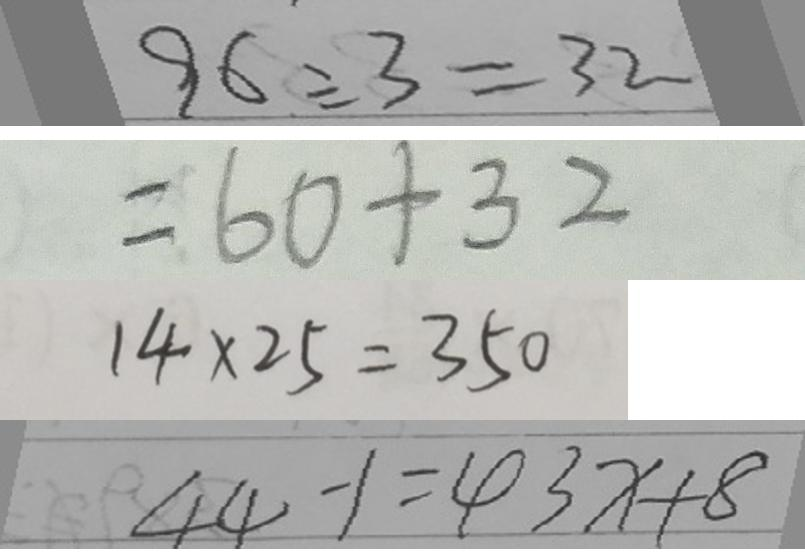Convert formula to latex. <formula><loc_0><loc_0><loc_500><loc_500>9 6 \div 3 = 3 2 
 = 6 0 + 3 2 
 1 4 \times 2 5 = 3 5 0 
 4 4 - 1 = 4 3 x + 8</formula> 